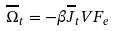Convert formula to latex. <formula><loc_0><loc_0><loc_500><loc_500>\overline { \Omega } _ { t } = - \beta \overline { J } _ { t } V F _ { e }</formula> 